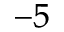<formula> <loc_0><loc_0><loc_500><loc_500>^ { - 5 }</formula> 